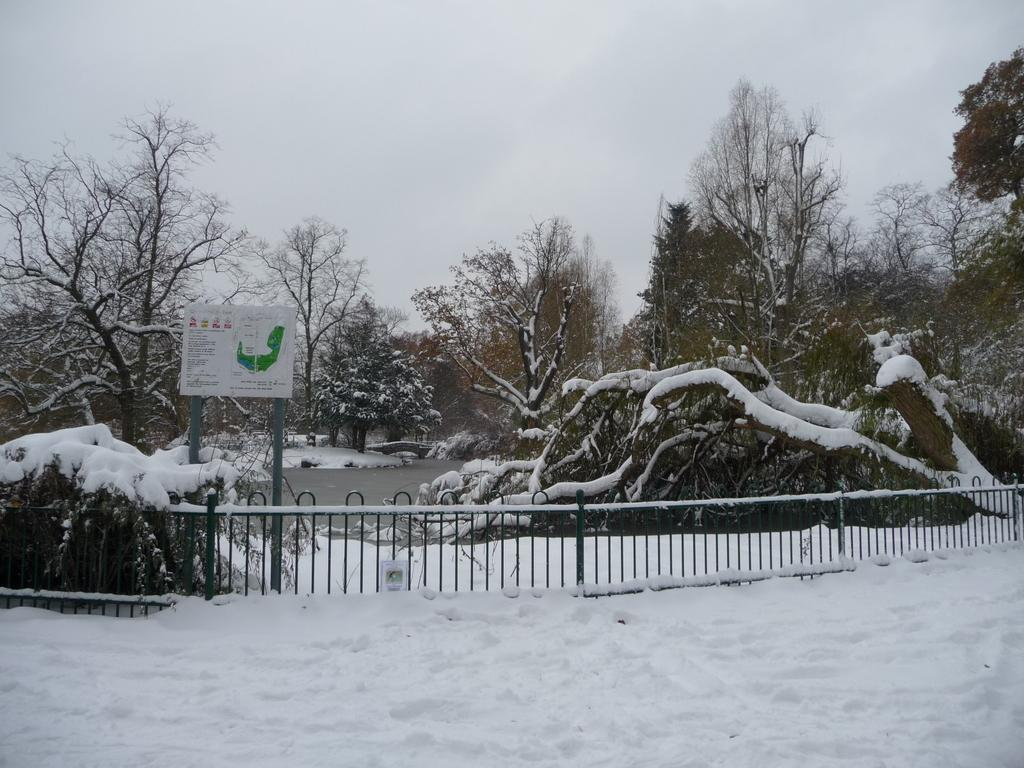What is the primary element covering the ground in the image? There is snow in the image. What type of structure can be seen in the image? There is fencing in the image. What can be seen in the distance in the image? There is water and trees visible in the background of the image. How would you describe the sky in the image? The sky is cloudy in the background of the image. What type of plant is growing in the tub in the image? There is no tub or plant present in the image. What is the doll doing in the image? There is no doll present in the image. 